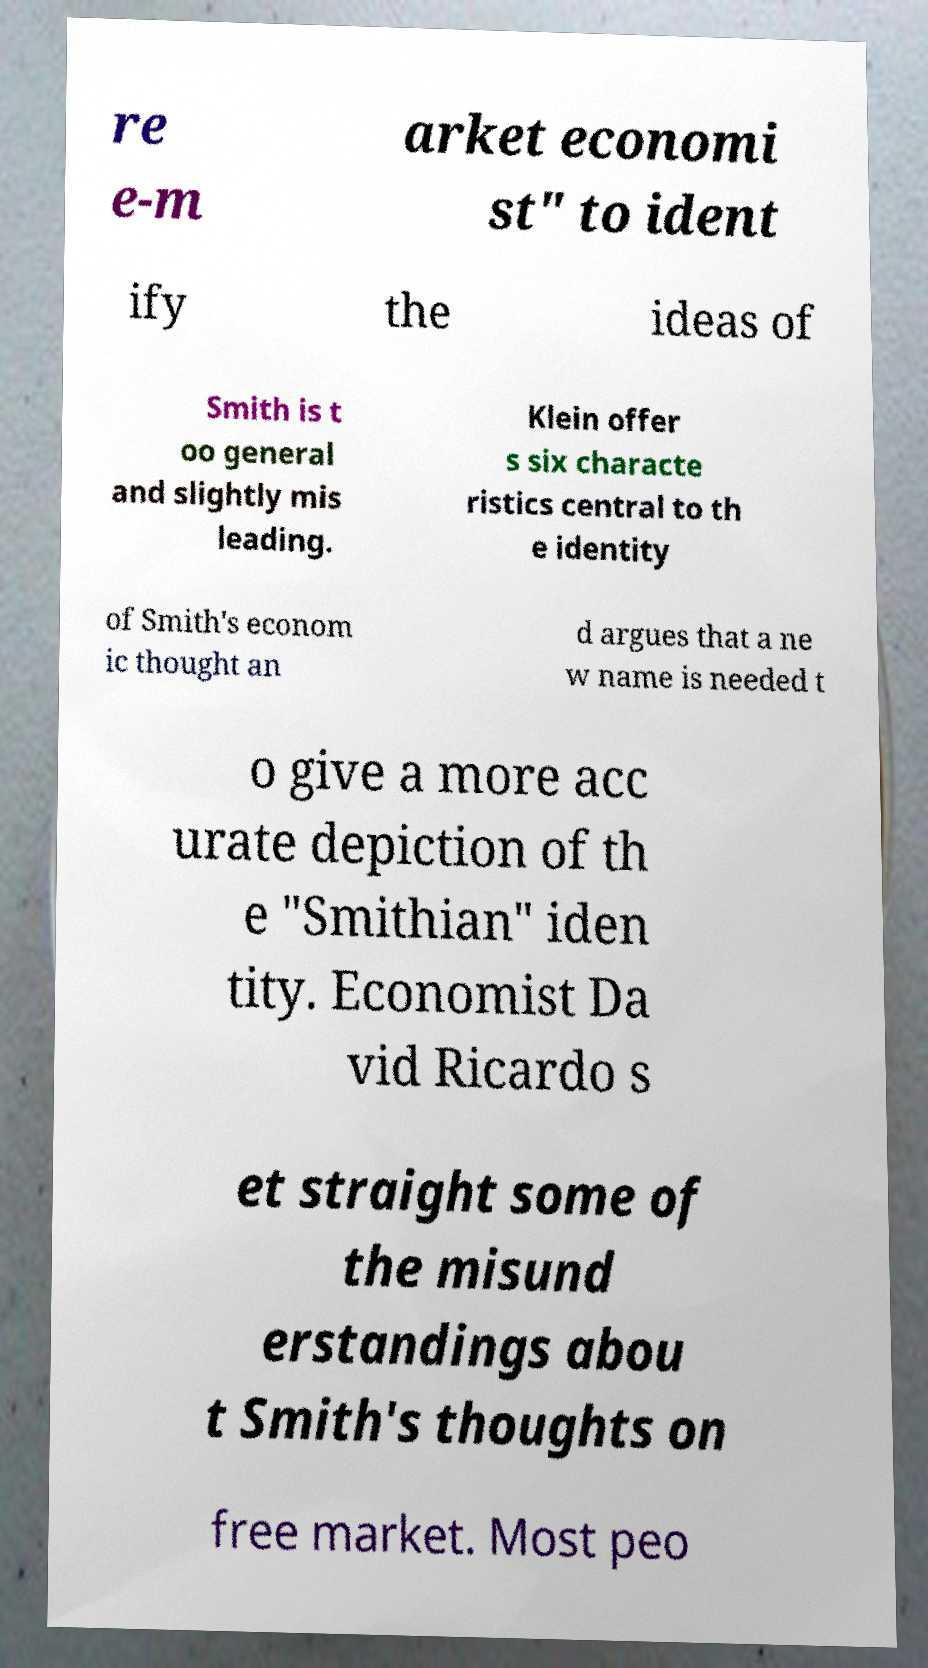Could you extract and type out the text from this image? re e-m arket economi st" to ident ify the ideas of Smith is t oo general and slightly mis leading. Klein offer s six characte ristics central to th e identity of Smith's econom ic thought an d argues that a ne w name is needed t o give a more acc urate depiction of th e "Smithian" iden tity. Economist Da vid Ricardo s et straight some of the misund erstandings abou t Smith's thoughts on free market. Most peo 